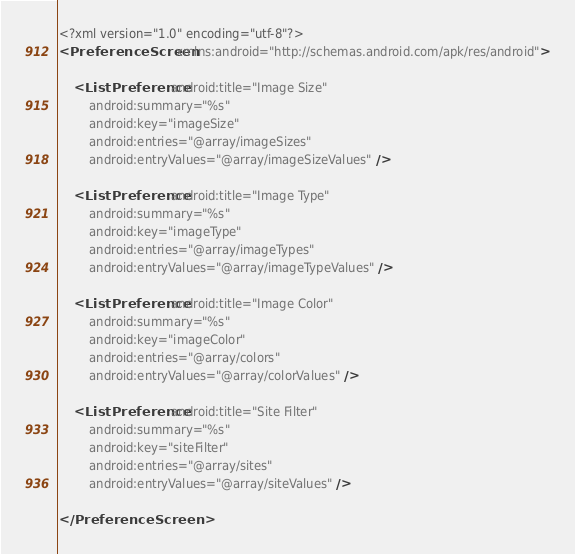Convert code to text. <code><loc_0><loc_0><loc_500><loc_500><_XML_><?xml version="1.0" encoding="utf-8"?>
<PreferenceScreen xmlns:android="http://schemas.android.com/apk/res/android">

    <ListPreference android:title="Image Size"
        android:summary="%s"
        android:key="imageSize"
        android:entries="@array/imageSizes"
        android:entryValues="@array/imageSizeValues" />

    <ListPreference android:title="Image Type"
        android:summary="%s"
        android:key="imageType"
        android:entries="@array/imageTypes"
        android:entryValues="@array/imageTypeValues" />

    <ListPreference android:title="Image Color"
        android:summary="%s"
        android:key="imageColor"
        android:entries="@array/colors"
        android:entryValues="@array/colorValues" />

    <ListPreference android:title="Site Filter"
        android:summary="%s"
        android:key="siteFilter"
        android:entries="@array/sites"
        android:entryValues="@array/siteValues" />

</PreferenceScreen></code> 